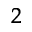Convert formula to latex. <formula><loc_0><loc_0><loc_500><loc_500>^ { 2 }</formula> 